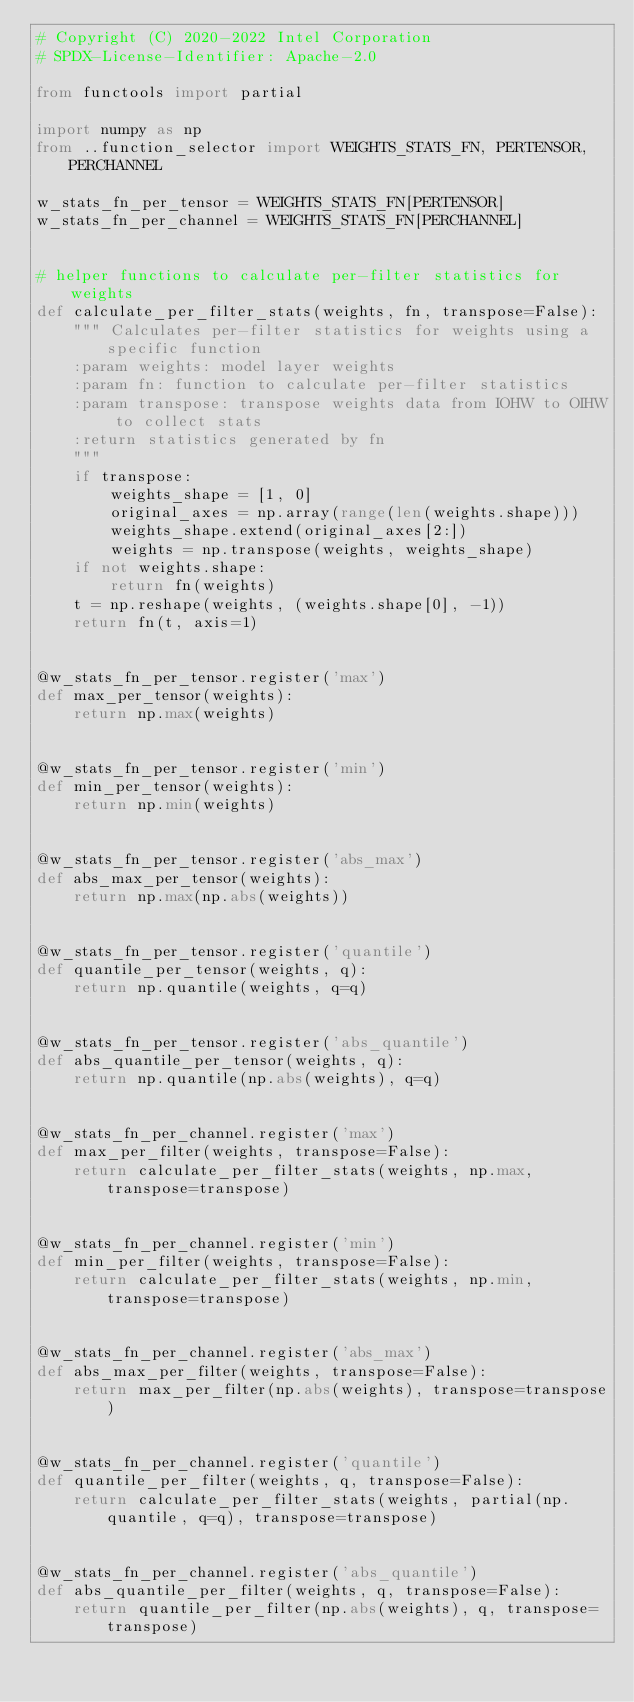Convert code to text. <code><loc_0><loc_0><loc_500><loc_500><_Python_># Copyright (C) 2020-2022 Intel Corporation
# SPDX-License-Identifier: Apache-2.0

from functools import partial

import numpy as np
from ..function_selector import WEIGHTS_STATS_FN, PERTENSOR, PERCHANNEL

w_stats_fn_per_tensor = WEIGHTS_STATS_FN[PERTENSOR]
w_stats_fn_per_channel = WEIGHTS_STATS_FN[PERCHANNEL]


# helper functions to calculate per-filter statistics for weights
def calculate_per_filter_stats(weights, fn, transpose=False):
    """ Calculates per-filter statistics for weights using a specific function
    :param weights: model layer weights
    :param fn: function to calculate per-filter statistics
    :param transpose: transpose weights data from IOHW to OIHW to collect stats
    :return statistics generated by fn
    """
    if transpose:
        weights_shape = [1, 0]
        original_axes = np.array(range(len(weights.shape)))
        weights_shape.extend(original_axes[2:])
        weights = np.transpose(weights, weights_shape)
    if not weights.shape:
        return fn(weights)
    t = np.reshape(weights, (weights.shape[0], -1))
    return fn(t, axis=1)


@w_stats_fn_per_tensor.register('max')
def max_per_tensor(weights):
    return np.max(weights)


@w_stats_fn_per_tensor.register('min')
def min_per_tensor(weights):
    return np.min(weights)


@w_stats_fn_per_tensor.register('abs_max')
def abs_max_per_tensor(weights):
    return np.max(np.abs(weights))


@w_stats_fn_per_tensor.register('quantile')
def quantile_per_tensor(weights, q):
    return np.quantile(weights, q=q)


@w_stats_fn_per_tensor.register('abs_quantile')
def abs_quantile_per_tensor(weights, q):
    return np.quantile(np.abs(weights), q=q)


@w_stats_fn_per_channel.register('max')
def max_per_filter(weights, transpose=False):
    return calculate_per_filter_stats(weights, np.max, transpose=transpose)


@w_stats_fn_per_channel.register('min')
def min_per_filter(weights, transpose=False):
    return calculate_per_filter_stats(weights, np.min, transpose=transpose)


@w_stats_fn_per_channel.register('abs_max')
def abs_max_per_filter(weights, transpose=False):
    return max_per_filter(np.abs(weights), transpose=transpose)


@w_stats_fn_per_channel.register('quantile')
def quantile_per_filter(weights, q, transpose=False):
    return calculate_per_filter_stats(weights, partial(np.quantile, q=q), transpose=transpose)


@w_stats_fn_per_channel.register('abs_quantile')
def abs_quantile_per_filter(weights, q, transpose=False):
    return quantile_per_filter(np.abs(weights), q, transpose=transpose)
</code> 